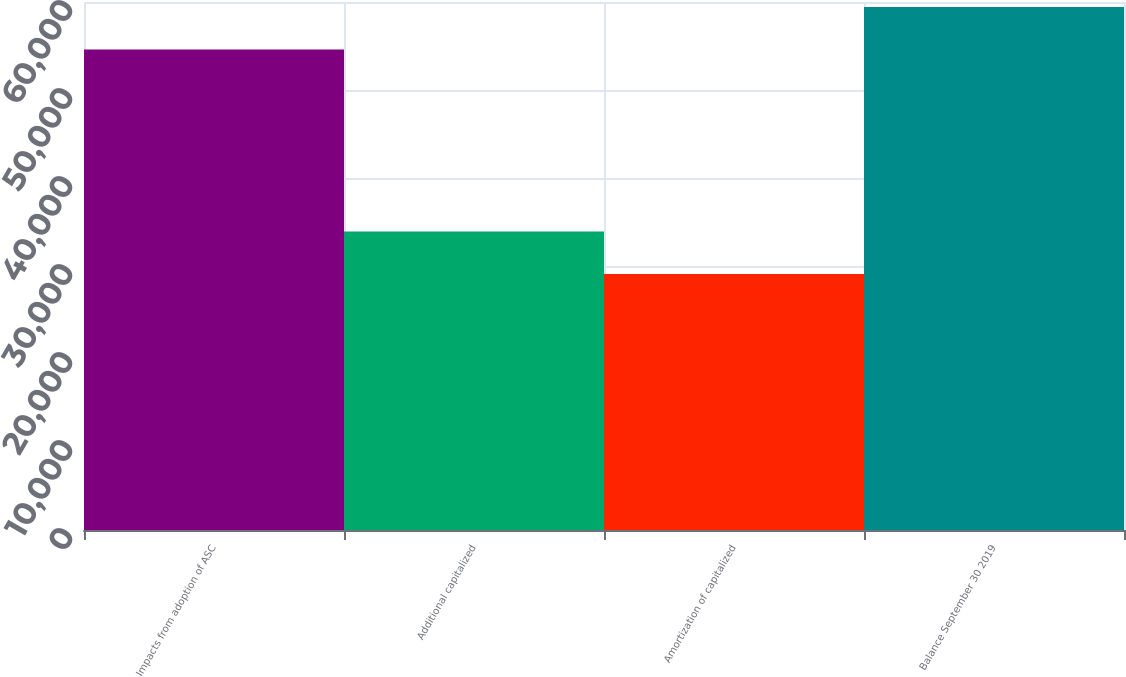<chart> <loc_0><loc_0><loc_500><loc_500><bar_chart><fcel>Impacts from adoption of ASC<fcel>Additional capitalized<fcel>Amortization of capitalized<fcel>Balance September 30 2019<nl><fcel>54608<fcel>33925<fcel>29087<fcel>59446<nl></chart> 